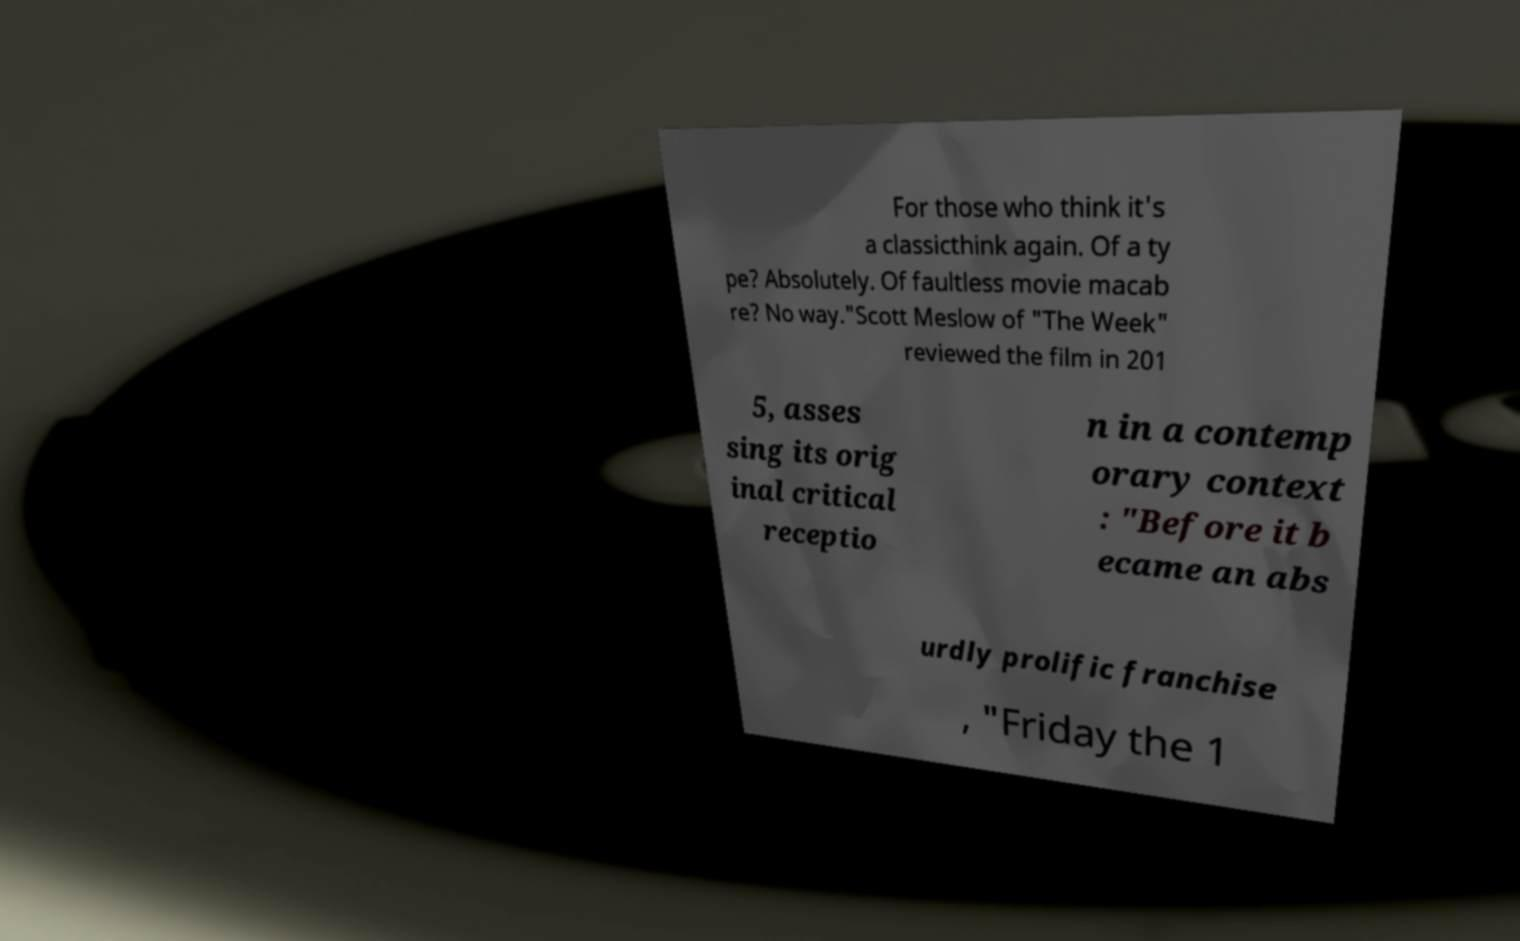I need the written content from this picture converted into text. Can you do that? For those who think it's a classicthink again. Of a ty pe? Absolutely. Of faultless movie macab re? No way."Scott Meslow of "The Week" reviewed the film in 201 5, asses sing its orig inal critical receptio n in a contemp orary context : "Before it b ecame an abs urdly prolific franchise , "Friday the 1 